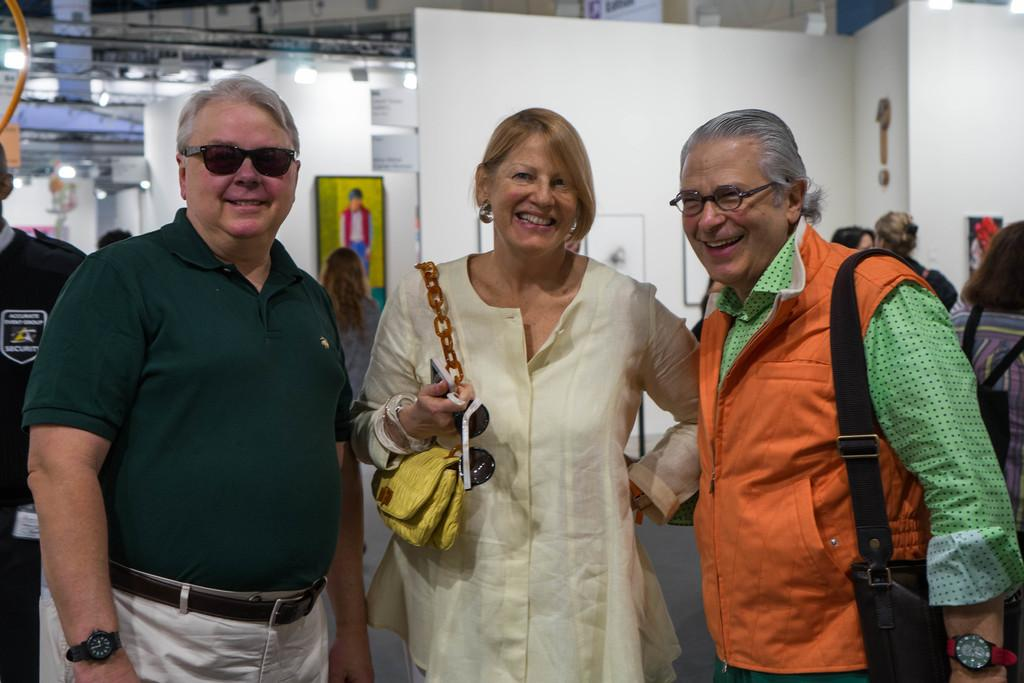How many people are present in the image? There are three people in the image. What is the facial expression of the people in the image? The three people are smiling. What can be seen in the background of the image? There is a group of people, lights, and some objects visible in the background. What type of scent can be detected in the image? There is no information about any scent in the image, so it cannot be determined. --- Facts: 1. There is a car in the image. 2. The car is red. 3. The car has four wheels. 4. There are people in the car. 5. The car is parked on the street. Absurd Topics: parrot, sand, dance Conversation: What is the main subject of the image? The main subject of the image is a car. What color is the car? The car is red. How many wheels does the car have? The car has four wheels. Are there any passengers in the car? Yes, there are people in the car. Where is the car located in the image? The car is parked on the street. Reasoning: Let's think step by step in order to produce the conversation. We start by identifying the main subject of the image, which is the car. Then, we describe the car's color and the number of wheels it has. Next, we mention the presence of passengers in the car. Finally, we describe the car's location, noting that it is parked on the street. Absurd Question/Answer: Can you see a parrot dancing on the sand in the image? No, there is no parrot or sand present in the image; it features a red car parked on the street with people inside. 